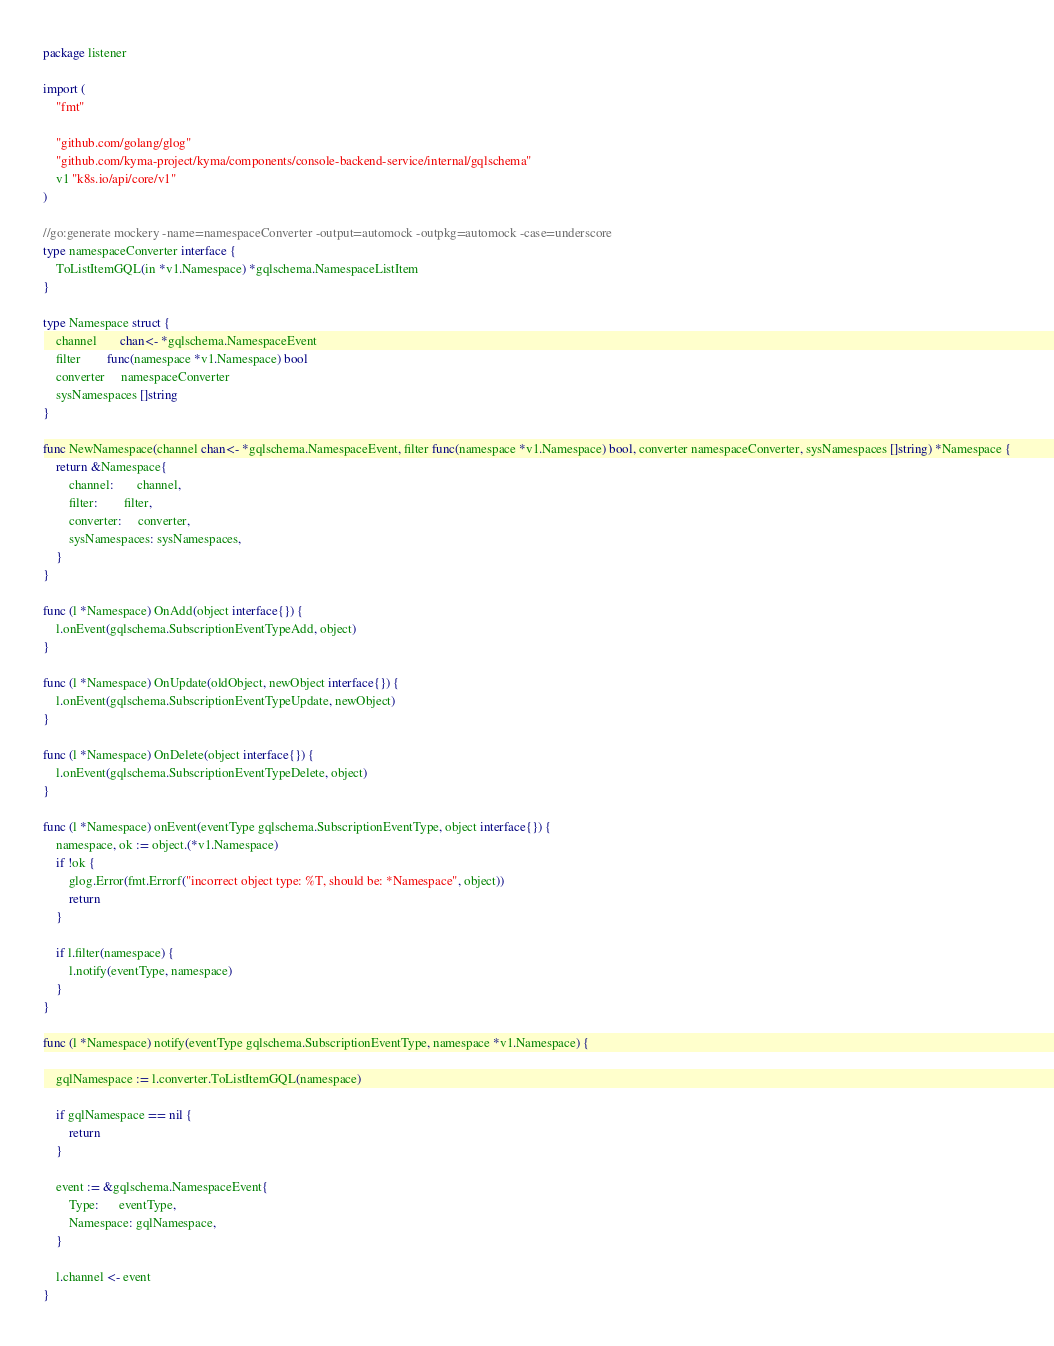Convert code to text. <code><loc_0><loc_0><loc_500><loc_500><_Go_>package listener

import (
	"fmt"

	"github.com/golang/glog"
	"github.com/kyma-project/kyma/components/console-backend-service/internal/gqlschema"
	v1 "k8s.io/api/core/v1"
)

//go:generate mockery -name=namespaceConverter -output=automock -outpkg=automock -case=underscore
type namespaceConverter interface {
	ToListItemGQL(in *v1.Namespace) *gqlschema.NamespaceListItem
}

type Namespace struct {
	channel       chan<- *gqlschema.NamespaceEvent
	filter        func(namespace *v1.Namespace) bool
	converter     namespaceConverter
	sysNamespaces []string
}

func NewNamespace(channel chan<- *gqlschema.NamespaceEvent, filter func(namespace *v1.Namespace) bool, converter namespaceConverter, sysNamespaces []string) *Namespace {
	return &Namespace{
		channel:       channel,
		filter:        filter,
		converter:     converter,
		sysNamespaces: sysNamespaces,
	}
}

func (l *Namespace) OnAdd(object interface{}) {
	l.onEvent(gqlschema.SubscriptionEventTypeAdd, object)
}

func (l *Namespace) OnUpdate(oldObject, newObject interface{}) {
	l.onEvent(gqlschema.SubscriptionEventTypeUpdate, newObject)
}

func (l *Namespace) OnDelete(object interface{}) {
	l.onEvent(gqlschema.SubscriptionEventTypeDelete, object)
}

func (l *Namespace) onEvent(eventType gqlschema.SubscriptionEventType, object interface{}) {
	namespace, ok := object.(*v1.Namespace)
	if !ok {
		glog.Error(fmt.Errorf("incorrect object type: %T, should be: *Namespace", object))
		return
	}

	if l.filter(namespace) {
		l.notify(eventType, namespace)
	}
}

func (l *Namespace) notify(eventType gqlschema.SubscriptionEventType, namespace *v1.Namespace) {

	gqlNamespace := l.converter.ToListItemGQL(namespace)

	if gqlNamespace == nil {
		return
	}

	event := &gqlschema.NamespaceEvent{
		Type:      eventType,
		Namespace: gqlNamespace,
	}

	l.channel <- event
}
</code> 